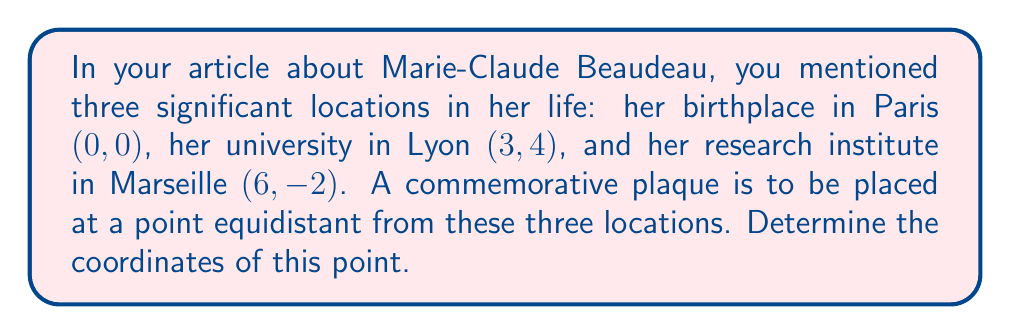Can you solve this math problem? To find the point equidistant from three given locations, we need to follow these steps:

1) The point we're looking for is the center of a circle that passes through all three given points. This center is the intersection of the perpendicular bisectors of any two sides of the triangle formed by the three points.

2) Let's choose two sides to work with: Paris to Lyon, and Paris to Marseille.

3) For Paris to Lyon:
   Midpoint: $(\frac{0+3}{2}, \frac{0+4}{2}) = (1.5, 2)$
   Vector from Paris to Lyon: $\vec{v_1} = (3-0, 4-0) = (3, 4)$
   Perpendicular vector: $\vec{n_1} = (-4, 3)$
   Equation of perpendicular bisector: $-4(x-1.5) + 3(y-2) = 0$
   Simplified: $4x - 3y - 2 = 0$

4) For Paris to Marseille:
   Midpoint: $(\frac{0+6}{2}, \frac{0-2}{2}) = (3, -1)$
   Vector from Paris to Marseille: $\vec{v_2} = (6-0, -2-0) = (6, -2)$
   Perpendicular vector: $\vec{n_2} = (2, 6)$
   Equation of perpendicular bisector: $2(x-3) + 6(y+1) = 0$
   Simplified: $x + 3y - 1 = 0$

5) To find the intersection of these two lines, we solve the system of equations:
   $4x - 3y - 2 = 0$
   $x + 3y - 1 = 0$

6) Multiplying the second equation by 4 and subtracting from the first:
   $4x - 3y - 2 = 0$
   $4x + 12y - 4 = 0$
   $-15y + 2 = 0$
   $y = \frac{2}{15}$

7) Substituting this y-value back into $x + 3y - 1 = 0$:
   $x + 3(\frac{2}{15}) - 1 = 0$
   $x = 1 - \frac{2}{5} = \frac{3}{5}$

Therefore, the coordinates of the equidistant point are $(\frac{3}{5}, \frac{2}{15})$.
Answer: $(\frac{3}{5}, \frac{2}{15})$ or approximately $(0.6, 0.133)$ 